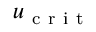Convert formula to latex. <formula><loc_0><loc_0><loc_500><loc_500>u _ { c r i t }</formula> 